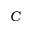<formula> <loc_0><loc_0><loc_500><loc_500>C</formula> 